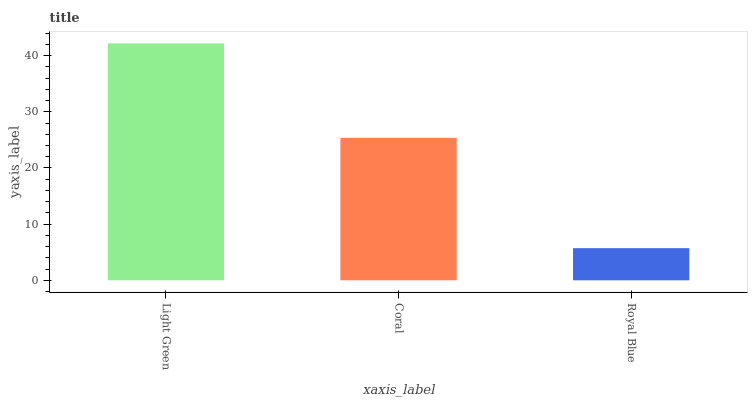Is Royal Blue the minimum?
Answer yes or no. Yes. Is Light Green the maximum?
Answer yes or no. Yes. Is Coral the minimum?
Answer yes or no. No. Is Coral the maximum?
Answer yes or no. No. Is Light Green greater than Coral?
Answer yes or no. Yes. Is Coral less than Light Green?
Answer yes or no. Yes. Is Coral greater than Light Green?
Answer yes or no. No. Is Light Green less than Coral?
Answer yes or no. No. Is Coral the high median?
Answer yes or no. Yes. Is Coral the low median?
Answer yes or no. Yes. Is Light Green the high median?
Answer yes or no. No. Is Light Green the low median?
Answer yes or no. No. 